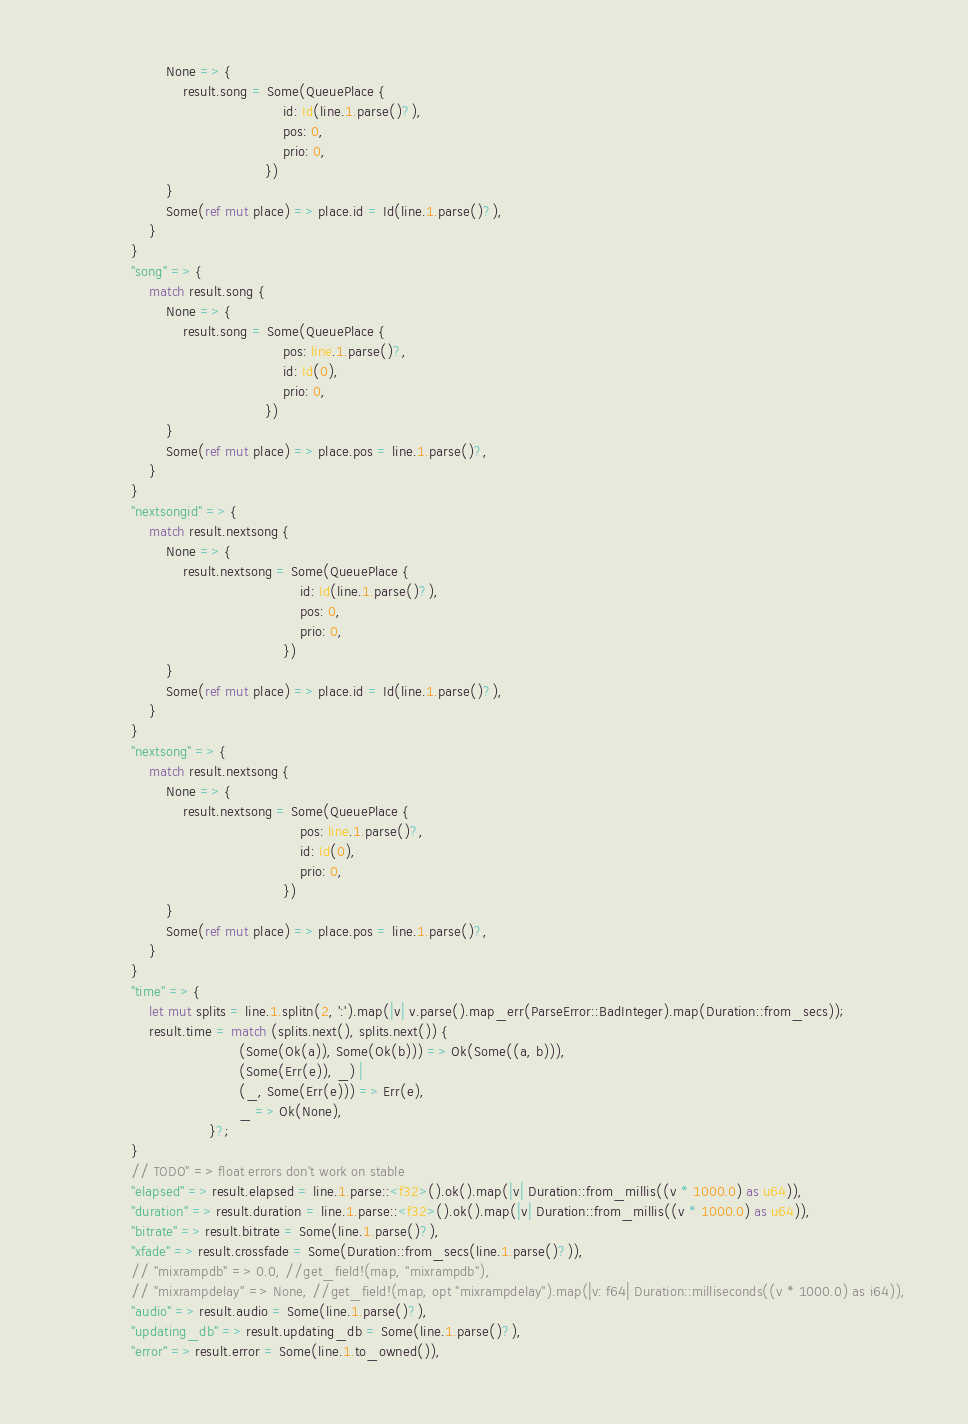<code> <loc_0><loc_0><loc_500><loc_500><_Rust_>                        None => {
                            result.song = Some(QueuePlace {
                                                   id: Id(line.1.parse()?),
                                                   pos: 0,
                                                   prio: 0,
                                               })
                        }
                        Some(ref mut place) => place.id = Id(line.1.parse()?),
                    }
                }
                "song" => {
                    match result.song {
                        None => {
                            result.song = Some(QueuePlace {
                                                   pos: line.1.parse()?,
                                                   id: Id(0),
                                                   prio: 0,
                                               })
                        }
                        Some(ref mut place) => place.pos = line.1.parse()?,
                    }
                }
                "nextsongid" => {
                    match result.nextsong {
                        None => {
                            result.nextsong = Some(QueuePlace {
                                                       id: Id(line.1.parse()?),
                                                       pos: 0,
                                                       prio: 0,
                                                   })
                        }
                        Some(ref mut place) => place.id = Id(line.1.parse()?),
                    }
                }
                "nextsong" => {
                    match result.nextsong {
                        None => {
                            result.nextsong = Some(QueuePlace {
                                                       pos: line.1.parse()?,
                                                       id: Id(0),
                                                       prio: 0,
                                                   })
                        }
                        Some(ref mut place) => place.pos = line.1.parse()?,
                    }
                }
                "time" => {
                    let mut splits = line.1.splitn(2, ':').map(|v| v.parse().map_err(ParseError::BadInteger).map(Duration::from_secs));
                    result.time = match (splits.next(), splits.next()) {
                                         (Some(Ok(a)), Some(Ok(b))) => Ok(Some((a, b))),
                                         (Some(Err(e)), _) |
                                         (_, Some(Err(e))) => Err(e),
                                         _ => Ok(None),
                                  }?;
                }
                // TODO" => float errors don't work on stable
                "elapsed" => result.elapsed = line.1.parse::<f32>().ok().map(|v| Duration::from_millis((v * 1000.0) as u64)),
                "duration" => result.duration = line.1.parse::<f32>().ok().map(|v| Duration::from_millis((v * 1000.0) as u64)),
                "bitrate" => result.bitrate = Some(line.1.parse()?),
                "xfade" => result.crossfade = Some(Duration::from_secs(line.1.parse()?)),
                // "mixrampdb" => 0.0, //get_field!(map, "mixrampdb"),
                // "mixrampdelay" => None, //get_field!(map, opt "mixrampdelay").map(|v: f64| Duration::milliseconds((v * 1000.0) as i64)),
                "audio" => result.audio = Some(line.1.parse()?),
                "updating_db" => result.updating_db = Some(line.1.parse()?),
                "error" => result.error = Some(line.1.to_owned()),</code> 